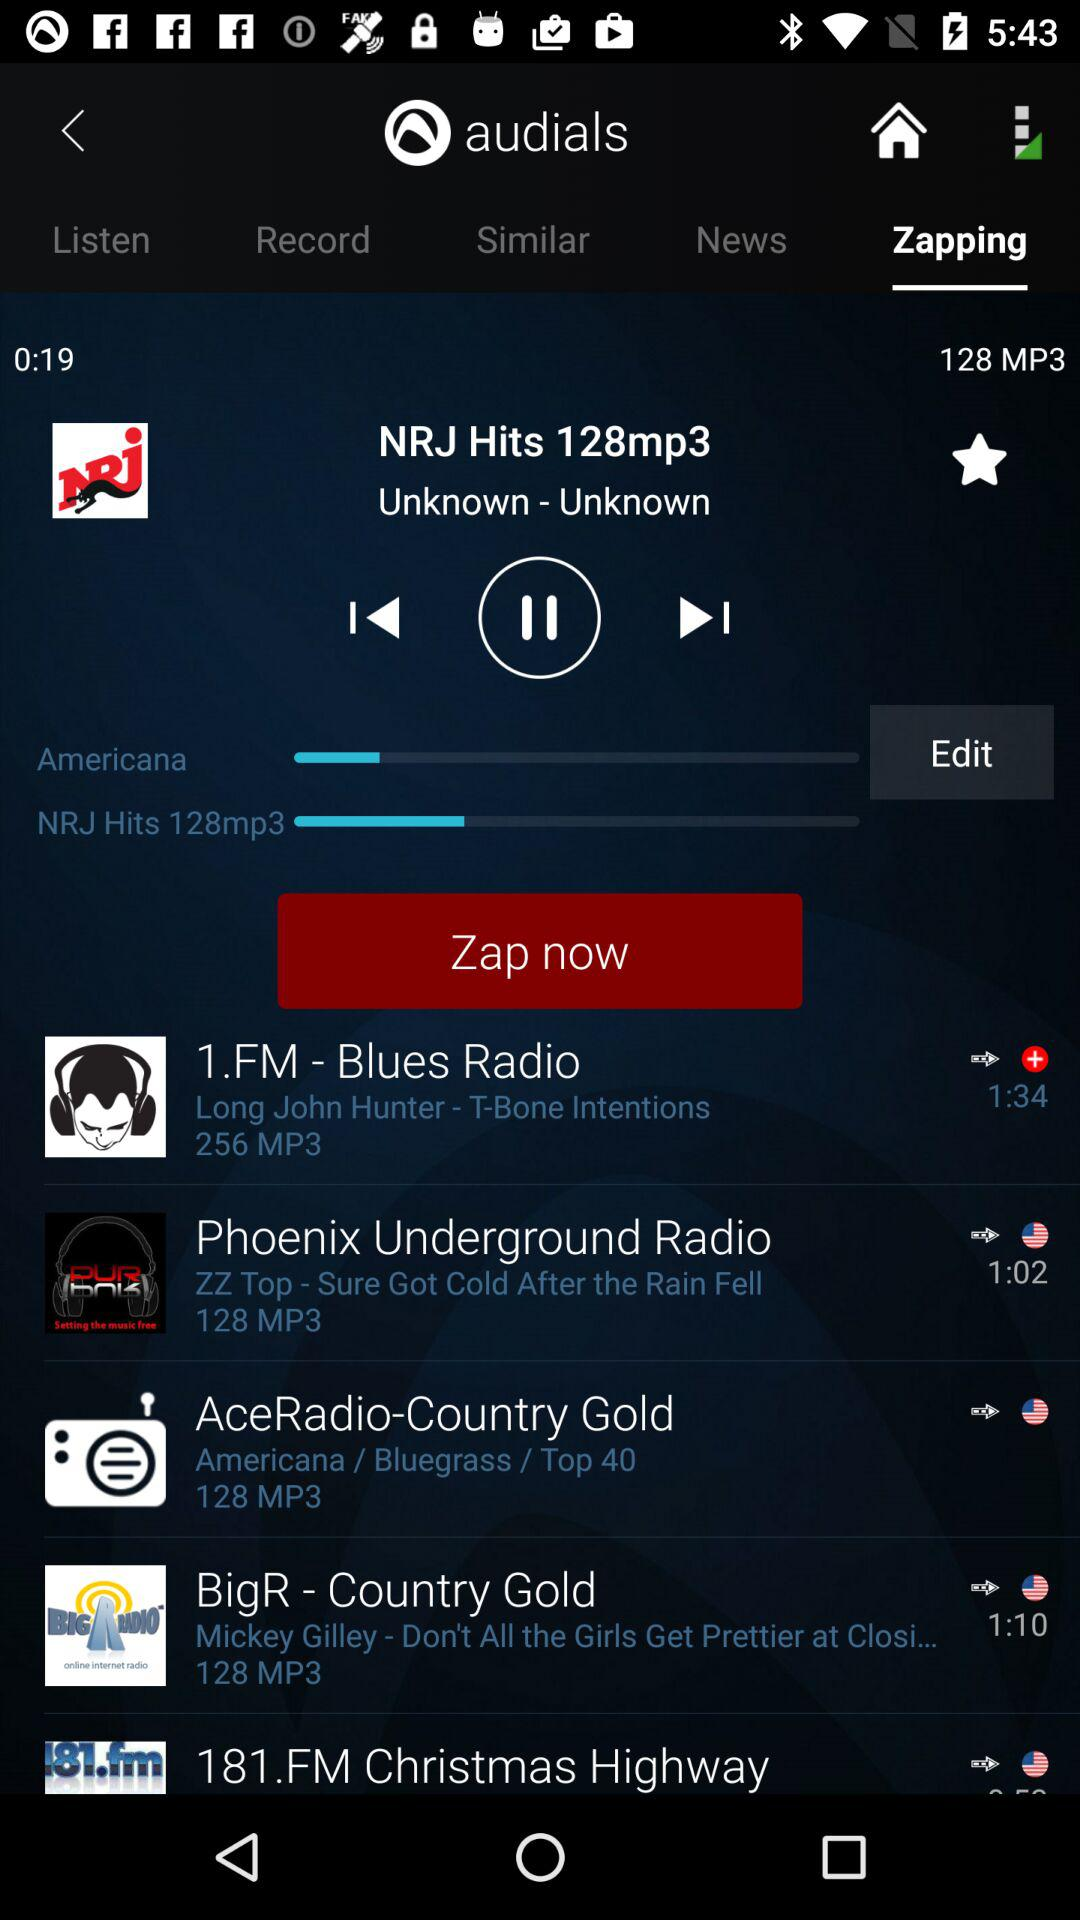What is the duration of "Blues Radio"? The duration of "Blues Radio" is 1 minute 34 seconds. 